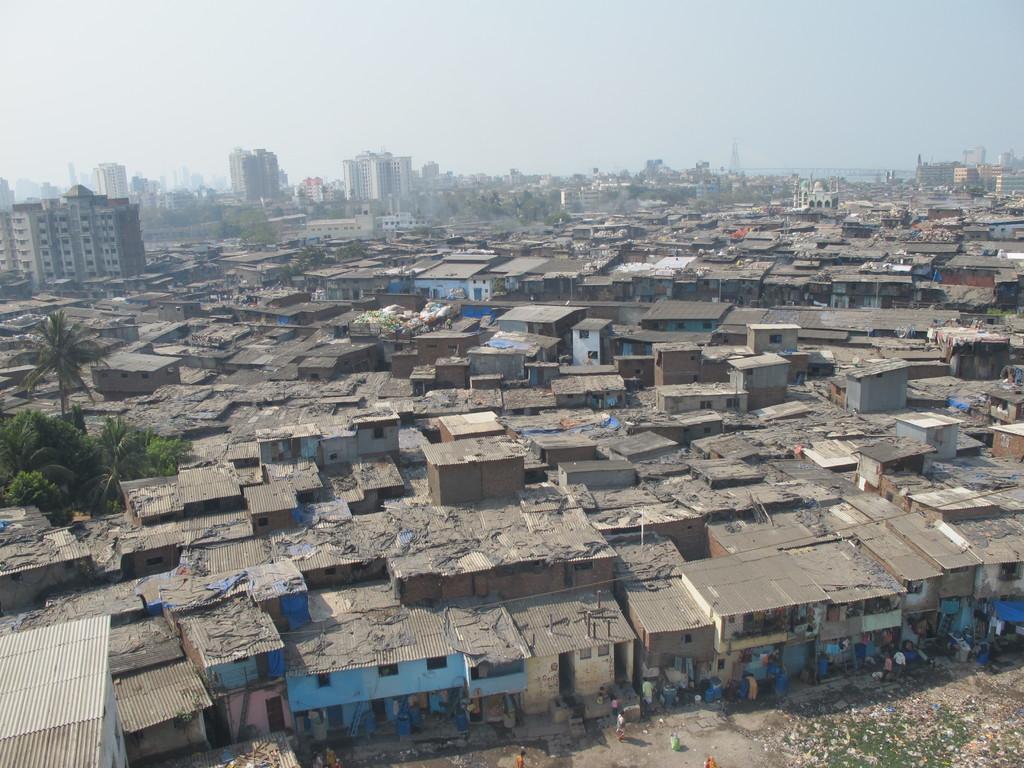Please provide a concise description of this image. In this picture we can see some people on the ground, buildings with windows, trees and in the background we can see the sky. 